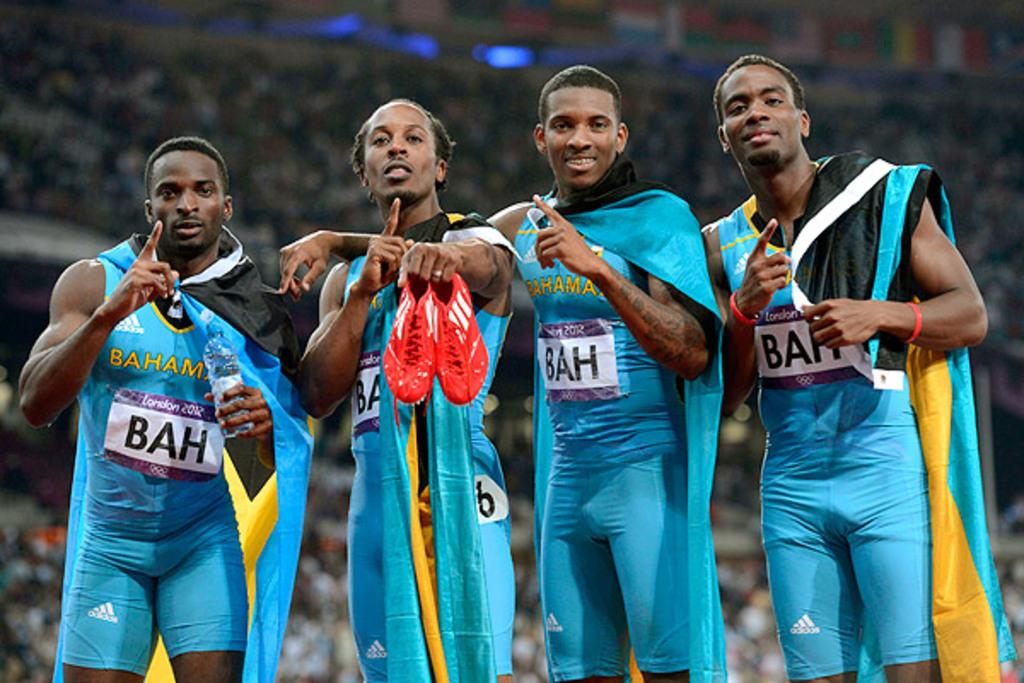<image>
Create a compact narrative representing the image presented. Athletes posing for a photo with one of them having a sign that says BAH. 